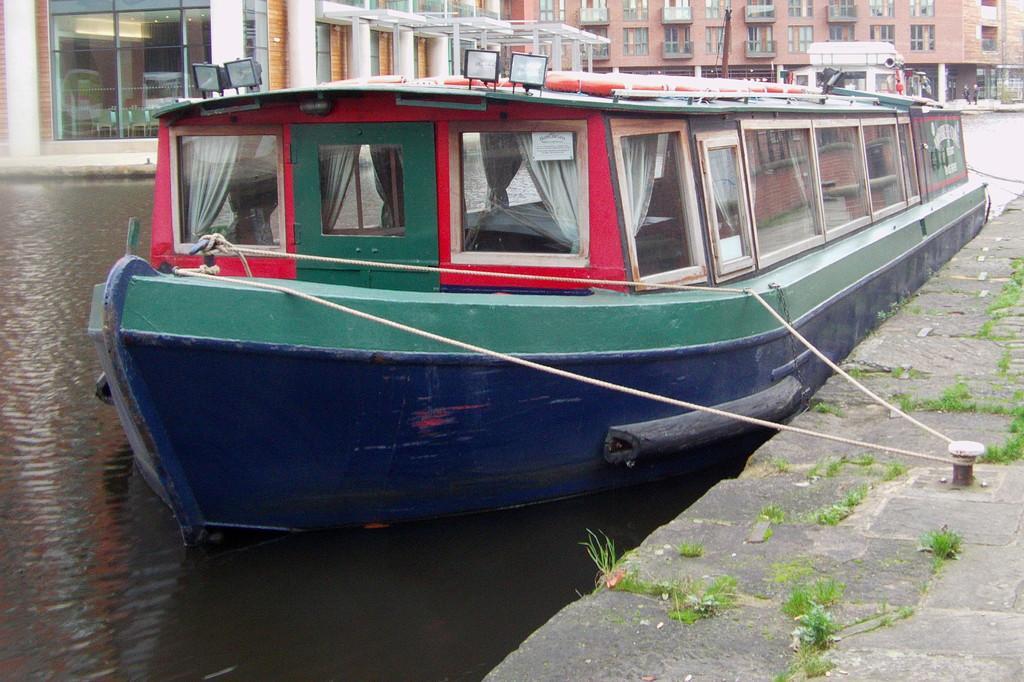Describe this image in one or two sentences. In this picture I can see the path on the right side of this picture and I see the grass on it and in the middle of this picture I can see the water on which there are boats and in the background I can see the buildings and few people. 